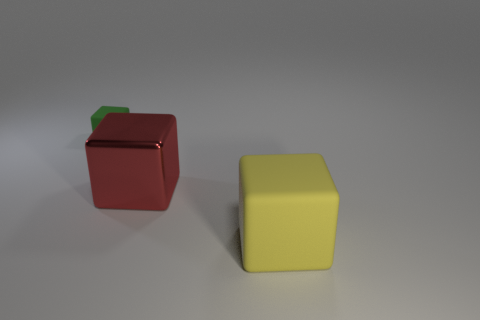Does the big thing to the left of the yellow rubber object have the same shape as the matte thing that is to the right of the green matte block?
Ensure brevity in your answer.  Yes. Is the size of the shiny cube the same as the rubber block that is in front of the small green cube?
Make the answer very short. Yes. Are there more small rubber cubes than blue metallic spheres?
Provide a short and direct response. Yes. Are the object that is in front of the metallic cube and the cube that is on the left side of the big metal object made of the same material?
Your answer should be compact. Yes. What is the material of the red cube?
Your answer should be very brief. Metal. Are there more small matte things to the left of the big yellow matte thing than tiny brown matte things?
Provide a succinct answer. Yes. What number of red metal cubes are left of the small matte block that is to the left of the big block that is behind the large yellow object?
Your answer should be very brief. 0. There is a cube that is both on the right side of the green block and behind the big matte block; what material is it?
Provide a succinct answer. Metal. What is the color of the small object?
Keep it short and to the point. Green. Are there more red things in front of the green block than large red objects that are on the left side of the red thing?
Give a very brief answer. Yes. 